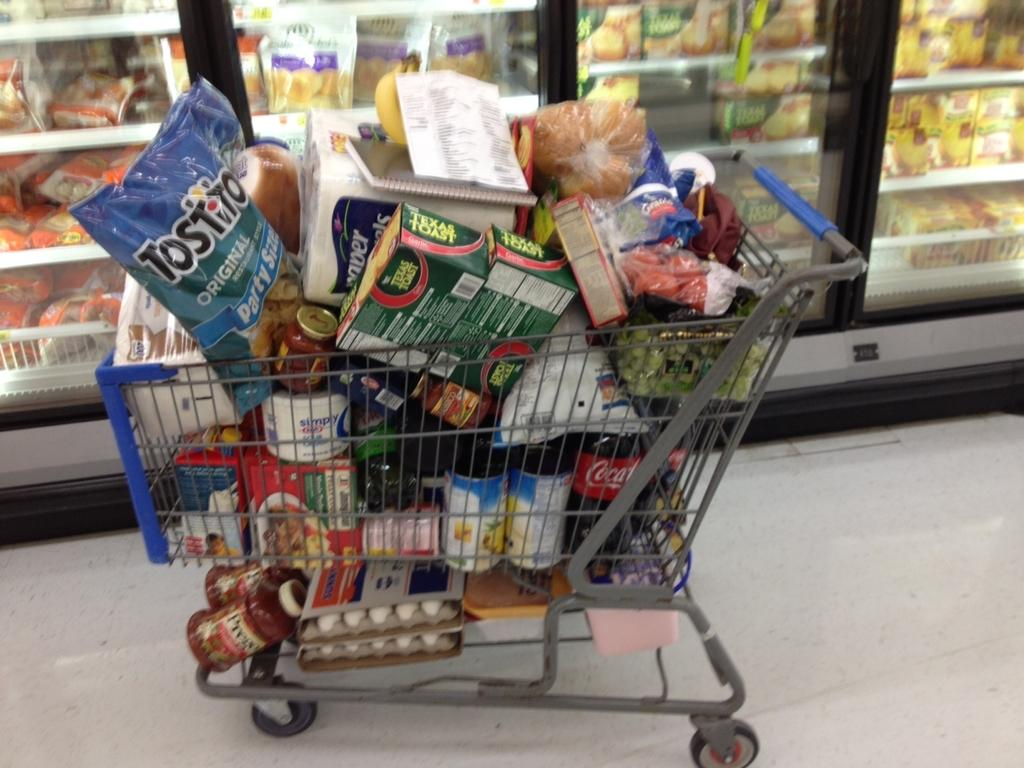<image>
Share a concise interpretation of the image provided. A shopping cart that is stuffed full of items including Tostito's chips and Coca Cola 